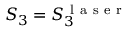Convert formula to latex. <formula><loc_0><loc_0><loc_500><loc_500>S _ { 3 } = S _ { 3 } ^ { l a s e r }</formula> 